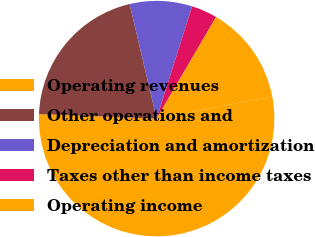Convert chart to OTSL. <chart><loc_0><loc_0><loc_500><loc_500><pie_chart><fcel>Operating revenues<fcel>Other operations and<fcel>Depreciation and amortization<fcel>Taxes other than income taxes<fcel>Operating income<nl><fcel>53.61%<fcel>20.7%<fcel>8.56%<fcel>3.56%<fcel>13.57%<nl></chart> 